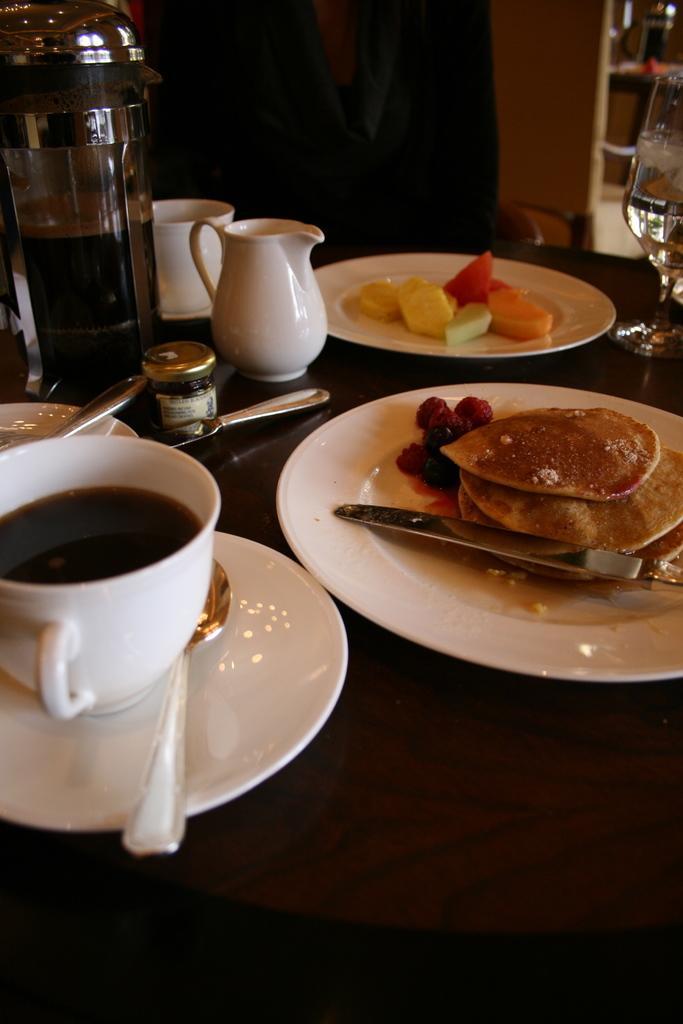How would you summarize this image in a sentence or two? In the middle there is a table on that table there is a plate ,jug ,cup,bottle,glass ,saucer and some food items ,in front of the table there is a person. I think this is a restaurant. 